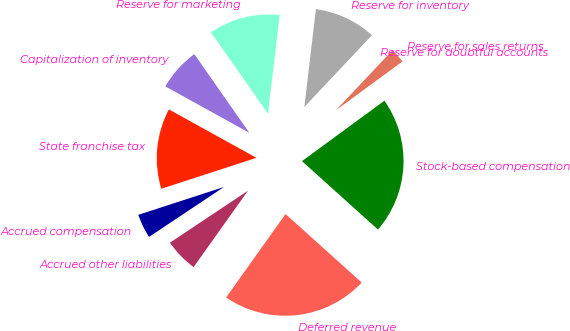Convert chart. <chart><loc_0><loc_0><loc_500><loc_500><pie_chart><fcel>Reserve for sales returns<fcel>Reserve for doubtful accounts<fcel>Reserve for inventory<fcel>Reserve for marketing<fcel>Capitalization of inventory<fcel>State franchise tax<fcel>Accrued compensation<fcel>Accrued other liabilities<fcel>Deferred revenue<fcel>Stock-based compensation<nl><fcel>2.9%<fcel>0.01%<fcel>10.14%<fcel>11.59%<fcel>7.25%<fcel>13.04%<fcel>4.35%<fcel>5.8%<fcel>23.18%<fcel>21.73%<nl></chart> 